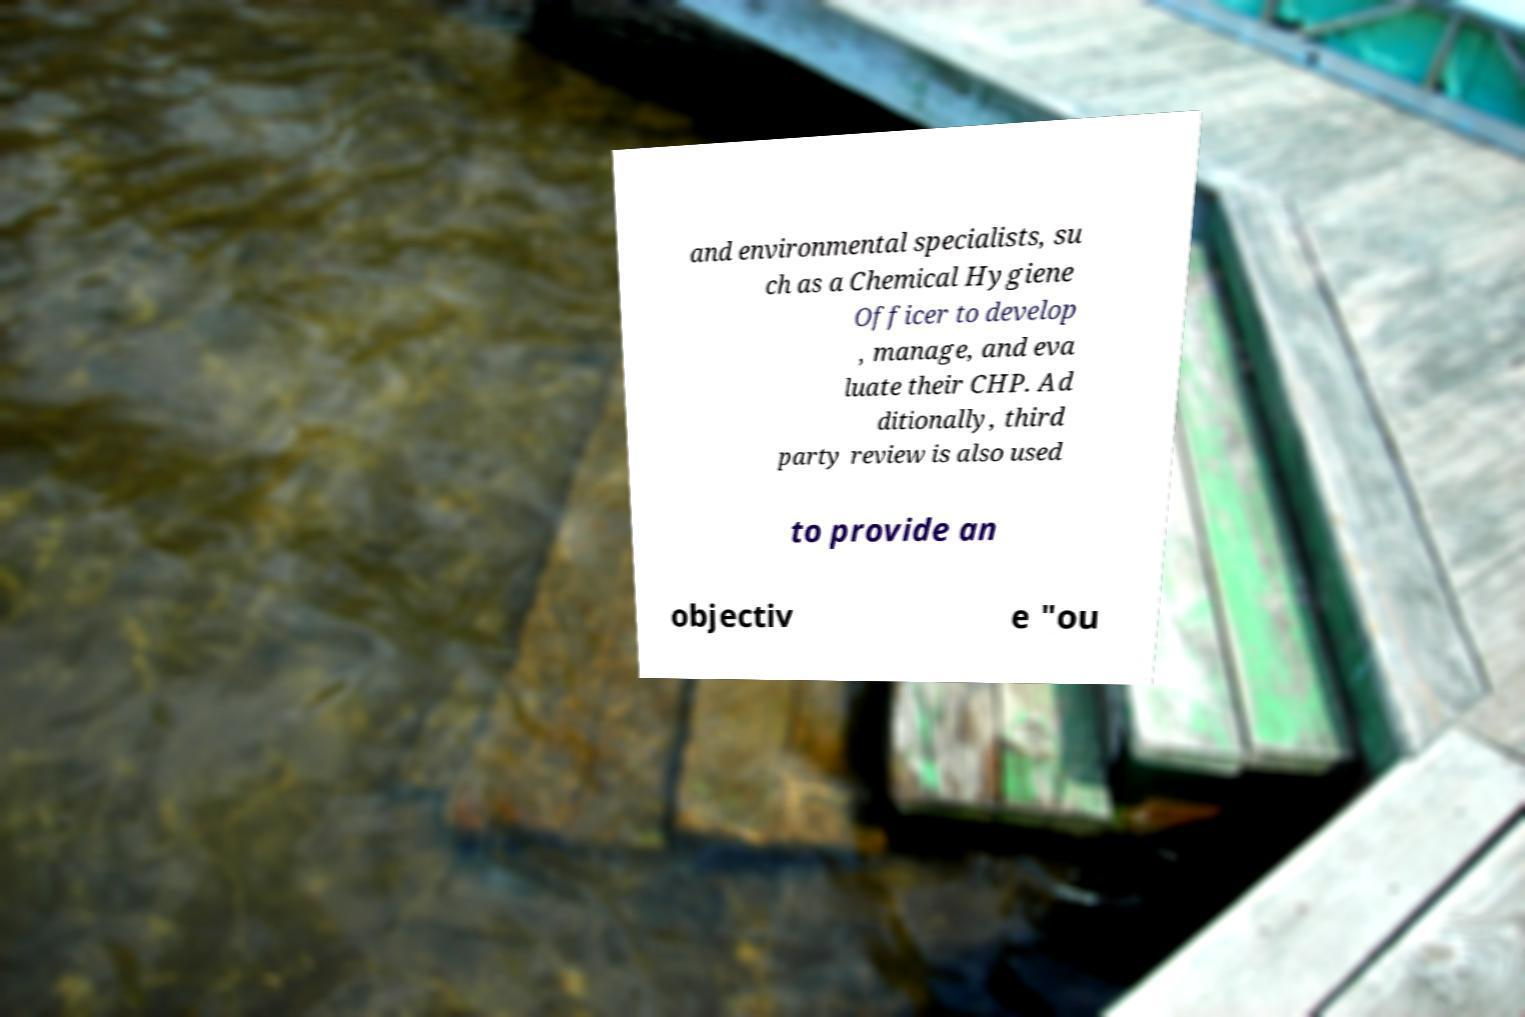Please identify and transcribe the text found in this image. and environmental specialists, su ch as a Chemical Hygiene Officer to develop , manage, and eva luate their CHP. Ad ditionally, third party review is also used to provide an objectiv e "ou 